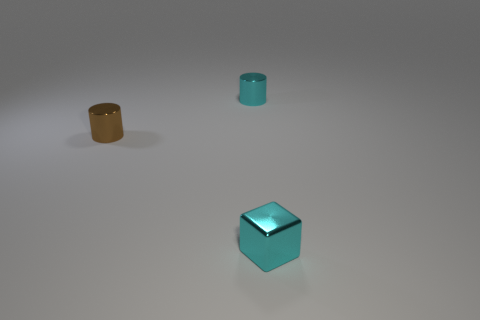Can you guess the material these objects are made of based on their appearance? Based on the reflections and the overall sheen, it's reasonable to guess that the objects are made of some type of metal. The smoothness and the way they reflect light hint at a polished metal surface. 